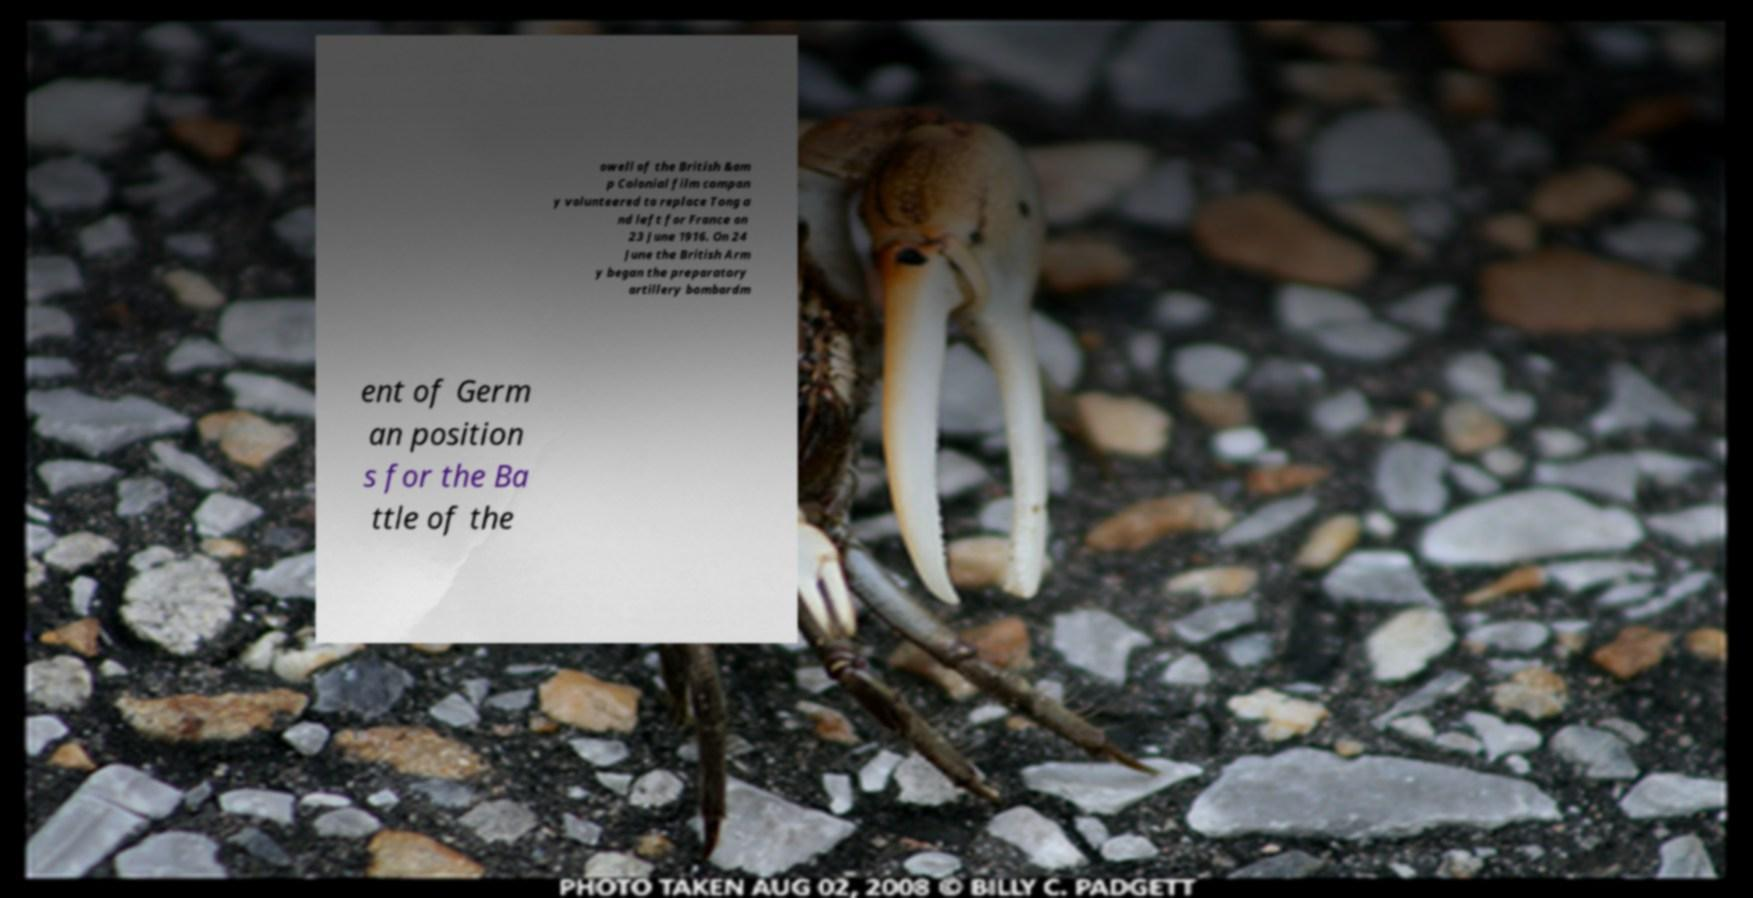Can you accurately transcribe the text from the provided image for me? owell of the British &am p Colonial film compan y volunteered to replace Tong a nd left for France on 23 June 1916. On 24 June the British Arm y began the preparatory artillery bombardm ent of Germ an position s for the Ba ttle of the 